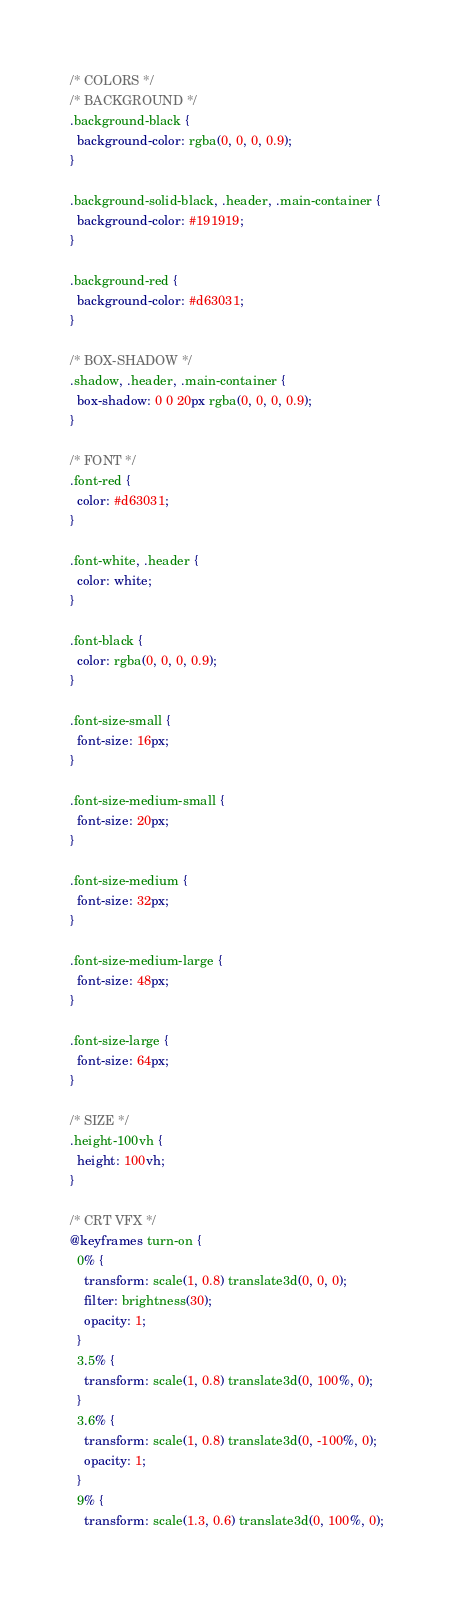<code> <loc_0><loc_0><loc_500><loc_500><_CSS_>/* COLORS */
/* BACKGROUND */
.background-black {
  background-color: rgba(0, 0, 0, 0.9);
}

.background-solid-black, .header, .main-container {
  background-color: #191919;
}

.background-red {
  background-color: #d63031;
}

/* BOX-SHADOW */
.shadow, .header, .main-container {
  box-shadow: 0 0 20px rgba(0, 0, 0, 0.9);
}

/* FONT */
.font-red {
  color: #d63031;
}

.font-white, .header {
  color: white;
}

.font-black {
  color: rgba(0, 0, 0, 0.9);
}

.font-size-small {
  font-size: 16px;
}

.font-size-medium-small {
  font-size: 20px;
}

.font-size-medium {
  font-size: 32px;
}

.font-size-medium-large {
  font-size: 48px;
}

.font-size-large {
  font-size: 64px;
}

/* SIZE */
.height-100vh {
  height: 100vh;
}

/* CRT VFX */
@keyframes turn-on {
  0% {
    transform: scale(1, 0.8) translate3d(0, 0, 0);
    filter: brightness(30);
    opacity: 1;
  }
  3.5% {
    transform: scale(1, 0.8) translate3d(0, 100%, 0);
  }
  3.6% {
    transform: scale(1, 0.8) translate3d(0, -100%, 0);
    opacity: 1;
  }
  9% {
    transform: scale(1.3, 0.6) translate3d(0, 100%, 0);</code> 